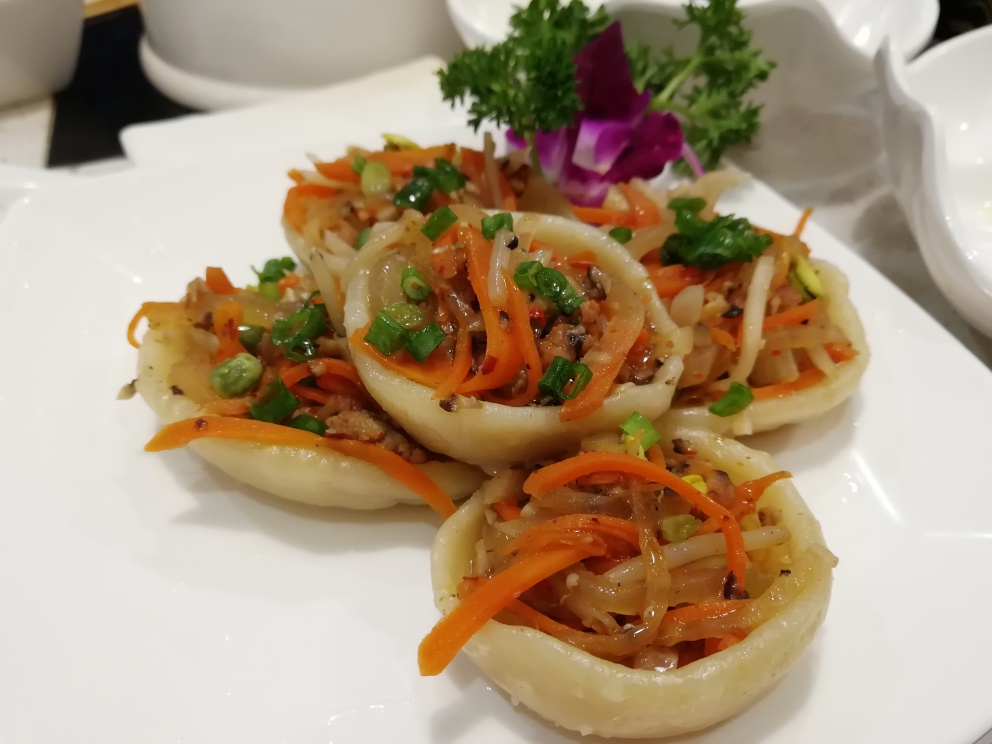This dish looks very appetizing. How would you describe its presentation and what does it say about the dining experience one might expect? The dish is presented with elegance and attention to detail, suggesting that the dining experience is likely to be high-end with an emphasis on culinary craftsmanship. The garnishes are thoughtfully placed, and the edible flower adds a touch of sophistication. It indicates that the restaurant values aesthetic appeal as much as flavor. Is there any nutritional consideration you can infer from the ingredients used in this dish? The dish appears to be a healthy choice, with a variety of vegetables providing essential nutrients and fiber. The use of meat indicates a source of protein, while the portion size suggests moderation. However, without knowledge of specific cooking techniques and additional ingredients, a complete nutritional assessment isn't possible. 